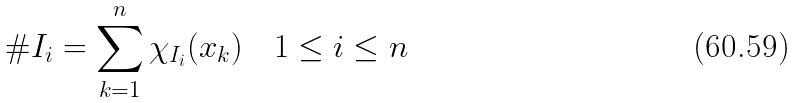<formula> <loc_0><loc_0><loc_500><loc_500>\# I _ { i } = \sum _ { k = 1 } ^ { n } \chi _ { I _ { i } } ( x _ { k } ) \quad 1 \leq i \leq n</formula> 